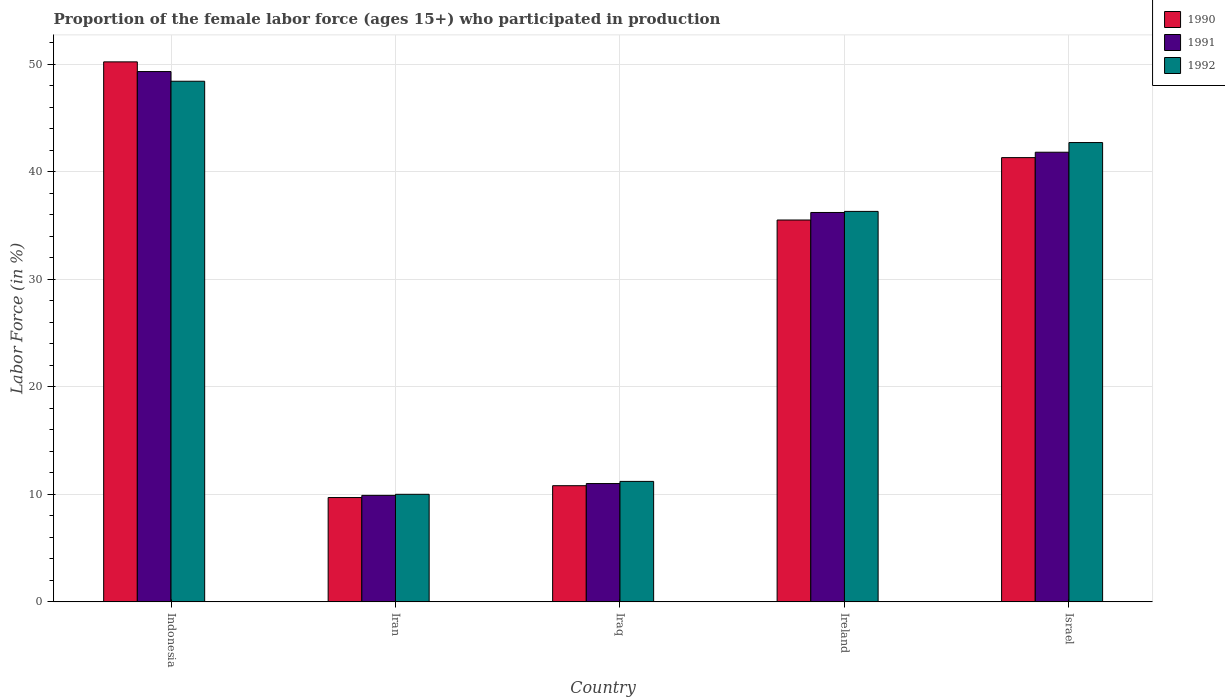How many different coloured bars are there?
Offer a very short reply. 3. How many groups of bars are there?
Make the answer very short. 5. How many bars are there on the 2nd tick from the left?
Make the answer very short. 3. How many bars are there on the 5th tick from the right?
Make the answer very short. 3. What is the label of the 3rd group of bars from the left?
Provide a succinct answer. Iraq. In how many cases, is the number of bars for a given country not equal to the number of legend labels?
Make the answer very short. 0. What is the proportion of the female labor force who participated in production in 1992 in Iran?
Provide a succinct answer. 10. Across all countries, what is the maximum proportion of the female labor force who participated in production in 1991?
Ensure brevity in your answer.  49.3. Across all countries, what is the minimum proportion of the female labor force who participated in production in 1992?
Offer a very short reply. 10. In which country was the proportion of the female labor force who participated in production in 1990 minimum?
Provide a succinct answer. Iran. What is the total proportion of the female labor force who participated in production in 1992 in the graph?
Offer a terse response. 148.6. What is the difference between the proportion of the female labor force who participated in production in 1992 in Iran and that in Israel?
Your answer should be very brief. -32.7. What is the difference between the proportion of the female labor force who participated in production in 1992 in Israel and the proportion of the female labor force who participated in production in 1991 in Indonesia?
Your response must be concise. -6.6. What is the average proportion of the female labor force who participated in production in 1990 per country?
Your response must be concise. 29.5. What is the difference between the proportion of the female labor force who participated in production of/in 1991 and proportion of the female labor force who participated in production of/in 1990 in Iraq?
Your response must be concise. 0.2. What is the ratio of the proportion of the female labor force who participated in production in 1990 in Iran to that in Israel?
Provide a short and direct response. 0.23. Is the proportion of the female labor force who participated in production in 1991 in Iran less than that in Israel?
Provide a succinct answer. Yes. What is the difference between the highest and the second highest proportion of the female labor force who participated in production in 1990?
Make the answer very short. -8.9. What is the difference between the highest and the lowest proportion of the female labor force who participated in production in 1990?
Keep it short and to the point. 40.5. In how many countries, is the proportion of the female labor force who participated in production in 1990 greater than the average proportion of the female labor force who participated in production in 1990 taken over all countries?
Keep it short and to the point. 3. What does the 1st bar from the left in Iraq represents?
Your answer should be compact. 1990. Is it the case that in every country, the sum of the proportion of the female labor force who participated in production in 1992 and proportion of the female labor force who participated in production in 1991 is greater than the proportion of the female labor force who participated in production in 1990?
Your answer should be compact. Yes. How many bars are there?
Your answer should be compact. 15. What is the difference between two consecutive major ticks on the Y-axis?
Make the answer very short. 10. How are the legend labels stacked?
Give a very brief answer. Vertical. What is the title of the graph?
Provide a short and direct response. Proportion of the female labor force (ages 15+) who participated in production. Does "2005" appear as one of the legend labels in the graph?
Provide a short and direct response. No. What is the label or title of the Y-axis?
Your response must be concise. Labor Force (in %). What is the Labor Force (in %) in 1990 in Indonesia?
Ensure brevity in your answer.  50.2. What is the Labor Force (in %) of 1991 in Indonesia?
Your response must be concise. 49.3. What is the Labor Force (in %) of 1992 in Indonesia?
Your response must be concise. 48.4. What is the Labor Force (in %) of 1990 in Iran?
Offer a terse response. 9.7. What is the Labor Force (in %) in 1991 in Iran?
Offer a very short reply. 9.9. What is the Labor Force (in %) in 1990 in Iraq?
Your answer should be very brief. 10.8. What is the Labor Force (in %) of 1992 in Iraq?
Offer a very short reply. 11.2. What is the Labor Force (in %) in 1990 in Ireland?
Ensure brevity in your answer.  35.5. What is the Labor Force (in %) of 1991 in Ireland?
Your answer should be compact. 36.2. What is the Labor Force (in %) in 1992 in Ireland?
Provide a short and direct response. 36.3. What is the Labor Force (in %) of 1990 in Israel?
Ensure brevity in your answer.  41.3. What is the Labor Force (in %) of 1991 in Israel?
Provide a short and direct response. 41.8. What is the Labor Force (in %) of 1992 in Israel?
Your response must be concise. 42.7. Across all countries, what is the maximum Labor Force (in %) in 1990?
Make the answer very short. 50.2. Across all countries, what is the maximum Labor Force (in %) of 1991?
Keep it short and to the point. 49.3. Across all countries, what is the maximum Labor Force (in %) in 1992?
Provide a succinct answer. 48.4. Across all countries, what is the minimum Labor Force (in %) of 1990?
Offer a terse response. 9.7. Across all countries, what is the minimum Labor Force (in %) in 1991?
Your answer should be compact. 9.9. Across all countries, what is the minimum Labor Force (in %) in 1992?
Provide a succinct answer. 10. What is the total Labor Force (in %) of 1990 in the graph?
Provide a succinct answer. 147.5. What is the total Labor Force (in %) of 1991 in the graph?
Your response must be concise. 148.2. What is the total Labor Force (in %) of 1992 in the graph?
Ensure brevity in your answer.  148.6. What is the difference between the Labor Force (in %) in 1990 in Indonesia and that in Iran?
Give a very brief answer. 40.5. What is the difference between the Labor Force (in %) of 1991 in Indonesia and that in Iran?
Your answer should be very brief. 39.4. What is the difference between the Labor Force (in %) in 1992 in Indonesia and that in Iran?
Make the answer very short. 38.4. What is the difference between the Labor Force (in %) in 1990 in Indonesia and that in Iraq?
Provide a short and direct response. 39.4. What is the difference between the Labor Force (in %) of 1991 in Indonesia and that in Iraq?
Give a very brief answer. 38.3. What is the difference between the Labor Force (in %) in 1992 in Indonesia and that in Iraq?
Provide a short and direct response. 37.2. What is the difference between the Labor Force (in %) of 1990 in Indonesia and that in Ireland?
Offer a terse response. 14.7. What is the difference between the Labor Force (in %) of 1991 in Indonesia and that in Ireland?
Your answer should be very brief. 13.1. What is the difference between the Labor Force (in %) of 1990 in Indonesia and that in Israel?
Keep it short and to the point. 8.9. What is the difference between the Labor Force (in %) in 1992 in Indonesia and that in Israel?
Ensure brevity in your answer.  5.7. What is the difference between the Labor Force (in %) in 1991 in Iran and that in Iraq?
Offer a very short reply. -1.1. What is the difference between the Labor Force (in %) in 1990 in Iran and that in Ireland?
Keep it short and to the point. -25.8. What is the difference between the Labor Force (in %) in 1991 in Iran and that in Ireland?
Your response must be concise. -26.3. What is the difference between the Labor Force (in %) of 1992 in Iran and that in Ireland?
Make the answer very short. -26.3. What is the difference between the Labor Force (in %) of 1990 in Iran and that in Israel?
Your answer should be compact. -31.6. What is the difference between the Labor Force (in %) of 1991 in Iran and that in Israel?
Offer a terse response. -31.9. What is the difference between the Labor Force (in %) of 1992 in Iran and that in Israel?
Provide a short and direct response. -32.7. What is the difference between the Labor Force (in %) of 1990 in Iraq and that in Ireland?
Your response must be concise. -24.7. What is the difference between the Labor Force (in %) in 1991 in Iraq and that in Ireland?
Offer a terse response. -25.2. What is the difference between the Labor Force (in %) in 1992 in Iraq and that in Ireland?
Provide a short and direct response. -25.1. What is the difference between the Labor Force (in %) in 1990 in Iraq and that in Israel?
Provide a succinct answer. -30.5. What is the difference between the Labor Force (in %) of 1991 in Iraq and that in Israel?
Make the answer very short. -30.8. What is the difference between the Labor Force (in %) of 1992 in Iraq and that in Israel?
Make the answer very short. -31.5. What is the difference between the Labor Force (in %) in 1990 in Ireland and that in Israel?
Ensure brevity in your answer.  -5.8. What is the difference between the Labor Force (in %) of 1991 in Ireland and that in Israel?
Your answer should be very brief. -5.6. What is the difference between the Labor Force (in %) in 1990 in Indonesia and the Labor Force (in %) in 1991 in Iran?
Ensure brevity in your answer.  40.3. What is the difference between the Labor Force (in %) of 1990 in Indonesia and the Labor Force (in %) of 1992 in Iran?
Keep it short and to the point. 40.2. What is the difference between the Labor Force (in %) of 1991 in Indonesia and the Labor Force (in %) of 1992 in Iran?
Your answer should be compact. 39.3. What is the difference between the Labor Force (in %) of 1990 in Indonesia and the Labor Force (in %) of 1991 in Iraq?
Offer a very short reply. 39.2. What is the difference between the Labor Force (in %) of 1991 in Indonesia and the Labor Force (in %) of 1992 in Iraq?
Your response must be concise. 38.1. What is the difference between the Labor Force (in %) of 1990 in Indonesia and the Labor Force (in %) of 1992 in Ireland?
Ensure brevity in your answer.  13.9. What is the difference between the Labor Force (in %) in 1991 in Indonesia and the Labor Force (in %) in 1992 in Ireland?
Ensure brevity in your answer.  13. What is the difference between the Labor Force (in %) in 1991 in Indonesia and the Labor Force (in %) in 1992 in Israel?
Your response must be concise. 6.6. What is the difference between the Labor Force (in %) of 1990 in Iran and the Labor Force (in %) of 1992 in Iraq?
Provide a short and direct response. -1.5. What is the difference between the Labor Force (in %) in 1991 in Iran and the Labor Force (in %) in 1992 in Iraq?
Offer a terse response. -1.3. What is the difference between the Labor Force (in %) of 1990 in Iran and the Labor Force (in %) of 1991 in Ireland?
Keep it short and to the point. -26.5. What is the difference between the Labor Force (in %) of 1990 in Iran and the Labor Force (in %) of 1992 in Ireland?
Offer a terse response. -26.6. What is the difference between the Labor Force (in %) of 1991 in Iran and the Labor Force (in %) of 1992 in Ireland?
Offer a very short reply. -26.4. What is the difference between the Labor Force (in %) in 1990 in Iran and the Labor Force (in %) in 1991 in Israel?
Ensure brevity in your answer.  -32.1. What is the difference between the Labor Force (in %) in 1990 in Iran and the Labor Force (in %) in 1992 in Israel?
Give a very brief answer. -33. What is the difference between the Labor Force (in %) in 1991 in Iran and the Labor Force (in %) in 1992 in Israel?
Your answer should be very brief. -32.8. What is the difference between the Labor Force (in %) in 1990 in Iraq and the Labor Force (in %) in 1991 in Ireland?
Provide a short and direct response. -25.4. What is the difference between the Labor Force (in %) of 1990 in Iraq and the Labor Force (in %) of 1992 in Ireland?
Provide a short and direct response. -25.5. What is the difference between the Labor Force (in %) of 1991 in Iraq and the Labor Force (in %) of 1992 in Ireland?
Ensure brevity in your answer.  -25.3. What is the difference between the Labor Force (in %) of 1990 in Iraq and the Labor Force (in %) of 1991 in Israel?
Make the answer very short. -31. What is the difference between the Labor Force (in %) of 1990 in Iraq and the Labor Force (in %) of 1992 in Israel?
Provide a short and direct response. -31.9. What is the difference between the Labor Force (in %) in 1991 in Iraq and the Labor Force (in %) in 1992 in Israel?
Ensure brevity in your answer.  -31.7. What is the difference between the Labor Force (in %) of 1990 in Ireland and the Labor Force (in %) of 1991 in Israel?
Your response must be concise. -6.3. What is the difference between the Labor Force (in %) in 1991 in Ireland and the Labor Force (in %) in 1992 in Israel?
Your answer should be compact. -6.5. What is the average Labor Force (in %) in 1990 per country?
Keep it short and to the point. 29.5. What is the average Labor Force (in %) of 1991 per country?
Your response must be concise. 29.64. What is the average Labor Force (in %) of 1992 per country?
Your answer should be very brief. 29.72. What is the difference between the Labor Force (in %) of 1990 and Labor Force (in %) of 1991 in Indonesia?
Offer a terse response. 0.9. What is the difference between the Labor Force (in %) in 1991 and Labor Force (in %) in 1992 in Indonesia?
Provide a short and direct response. 0.9. What is the difference between the Labor Force (in %) in 1990 and Labor Force (in %) in 1992 in Iran?
Keep it short and to the point. -0.3. What is the difference between the Labor Force (in %) of 1991 and Labor Force (in %) of 1992 in Iraq?
Your answer should be compact. -0.2. What is the difference between the Labor Force (in %) in 1990 and Labor Force (in %) in 1991 in Israel?
Your answer should be very brief. -0.5. What is the difference between the Labor Force (in %) of 1991 and Labor Force (in %) of 1992 in Israel?
Give a very brief answer. -0.9. What is the ratio of the Labor Force (in %) of 1990 in Indonesia to that in Iran?
Make the answer very short. 5.18. What is the ratio of the Labor Force (in %) in 1991 in Indonesia to that in Iran?
Offer a very short reply. 4.98. What is the ratio of the Labor Force (in %) of 1992 in Indonesia to that in Iran?
Your answer should be very brief. 4.84. What is the ratio of the Labor Force (in %) in 1990 in Indonesia to that in Iraq?
Keep it short and to the point. 4.65. What is the ratio of the Labor Force (in %) of 1991 in Indonesia to that in Iraq?
Your answer should be very brief. 4.48. What is the ratio of the Labor Force (in %) of 1992 in Indonesia to that in Iraq?
Your answer should be very brief. 4.32. What is the ratio of the Labor Force (in %) in 1990 in Indonesia to that in Ireland?
Provide a succinct answer. 1.41. What is the ratio of the Labor Force (in %) of 1991 in Indonesia to that in Ireland?
Give a very brief answer. 1.36. What is the ratio of the Labor Force (in %) in 1990 in Indonesia to that in Israel?
Your answer should be very brief. 1.22. What is the ratio of the Labor Force (in %) of 1991 in Indonesia to that in Israel?
Ensure brevity in your answer.  1.18. What is the ratio of the Labor Force (in %) of 1992 in Indonesia to that in Israel?
Your answer should be compact. 1.13. What is the ratio of the Labor Force (in %) in 1990 in Iran to that in Iraq?
Provide a succinct answer. 0.9. What is the ratio of the Labor Force (in %) of 1992 in Iran to that in Iraq?
Offer a terse response. 0.89. What is the ratio of the Labor Force (in %) of 1990 in Iran to that in Ireland?
Provide a short and direct response. 0.27. What is the ratio of the Labor Force (in %) of 1991 in Iran to that in Ireland?
Keep it short and to the point. 0.27. What is the ratio of the Labor Force (in %) in 1992 in Iran to that in Ireland?
Keep it short and to the point. 0.28. What is the ratio of the Labor Force (in %) of 1990 in Iran to that in Israel?
Ensure brevity in your answer.  0.23. What is the ratio of the Labor Force (in %) of 1991 in Iran to that in Israel?
Offer a very short reply. 0.24. What is the ratio of the Labor Force (in %) in 1992 in Iran to that in Israel?
Provide a succinct answer. 0.23. What is the ratio of the Labor Force (in %) of 1990 in Iraq to that in Ireland?
Your response must be concise. 0.3. What is the ratio of the Labor Force (in %) in 1991 in Iraq to that in Ireland?
Your answer should be compact. 0.3. What is the ratio of the Labor Force (in %) in 1992 in Iraq to that in Ireland?
Offer a terse response. 0.31. What is the ratio of the Labor Force (in %) of 1990 in Iraq to that in Israel?
Offer a very short reply. 0.26. What is the ratio of the Labor Force (in %) in 1991 in Iraq to that in Israel?
Give a very brief answer. 0.26. What is the ratio of the Labor Force (in %) in 1992 in Iraq to that in Israel?
Make the answer very short. 0.26. What is the ratio of the Labor Force (in %) of 1990 in Ireland to that in Israel?
Provide a succinct answer. 0.86. What is the ratio of the Labor Force (in %) in 1991 in Ireland to that in Israel?
Ensure brevity in your answer.  0.87. What is the ratio of the Labor Force (in %) of 1992 in Ireland to that in Israel?
Provide a succinct answer. 0.85. What is the difference between the highest and the second highest Labor Force (in %) of 1990?
Provide a short and direct response. 8.9. What is the difference between the highest and the second highest Labor Force (in %) in 1991?
Your answer should be very brief. 7.5. What is the difference between the highest and the second highest Labor Force (in %) in 1992?
Provide a short and direct response. 5.7. What is the difference between the highest and the lowest Labor Force (in %) of 1990?
Your answer should be compact. 40.5. What is the difference between the highest and the lowest Labor Force (in %) in 1991?
Make the answer very short. 39.4. What is the difference between the highest and the lowest Labor Force (in %) in 1992?
Make the answer very short. 38.4. 